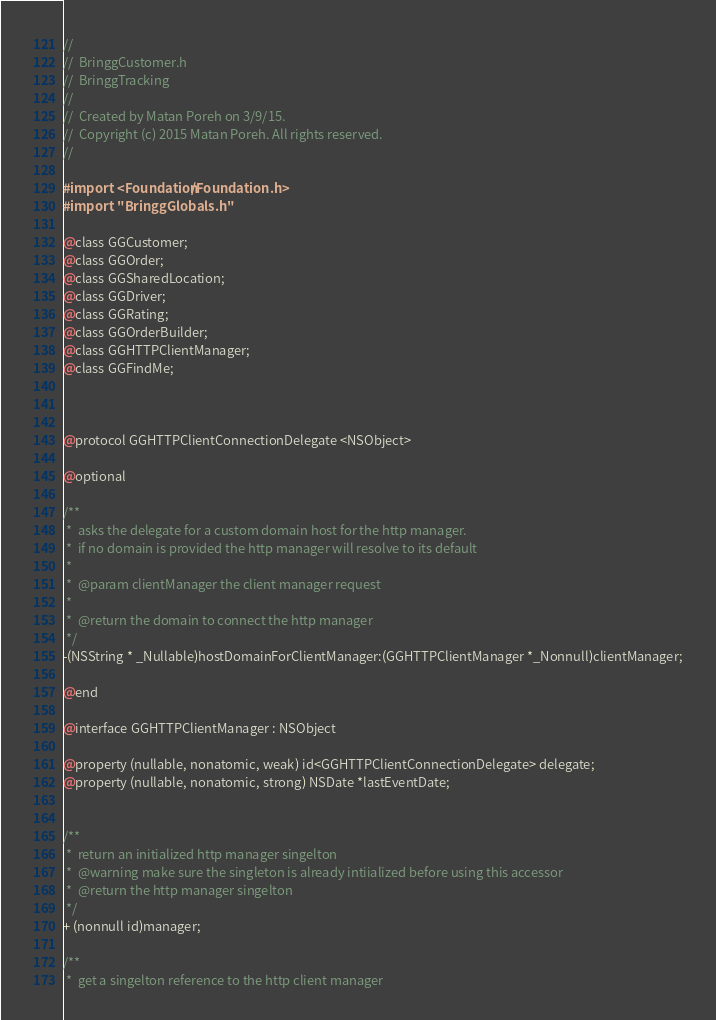<code> <loc_0><loc_0><loc_500><loc_500><_C_>//
//  BringgCustomer.h
//  BringgTracking
//
//  Created by Matan Poreh on 3/9/15.
//  Copyright (c) 2015 Matan Poreh. All rights reserved.
//

#import <Foundation/Foundation.h>
#import "BringgGlobals.h"

@class GGCustomer;
@class GGOrder;
@class GGSharedLocation;
@class GGDriver;
@class GGRating;
@class GGOrderBuilder;
@class GGHTTPClientManager;
@class GGFindMe;



@protocol GGHTTPClientConnectionDelegate <NSObject>

@optional

/**
 *  asks the delegate for a custom domain host for the http manager.
 *  if no domain is provided the http manager will resolve to its default
 *
 *  @param clientManager the client manager request
 *
 *  @return the domain to connect the http manager
 */
-(NSString * _Nullable)hostDomainForClientManager:(GGHTTPClientManager *_Nonnull)clientManager;

@end

@interface GGHTTPClientManager : NSObject

@property (nullable, nonatomic, weak) id<GGHTTPClientConnectionDelegate> delegate;
@property (nullable, nonatomic, strong) NSDate *lastEventDate;


/**
 *  return an initialized http manager singelton
 *  @warning make sure the singleton is already intiialized before using this accessor
 *  @return the http manager singelton
 */
+ (nonnull id)manager;

/**
 *  get a singelton reference to the http client manager</code> 